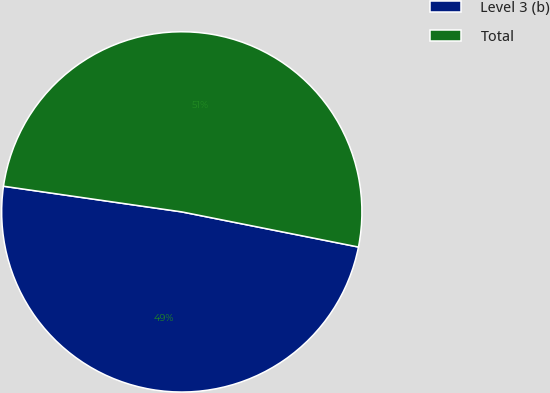Convert chart. <chart><loc_0><loc_0><loc_500><loc_500><pie_chart><fcel>Level 3 (b)<fcel>Total<nl><fcel>49.15%<fcel>50.85%<nl></chart> 